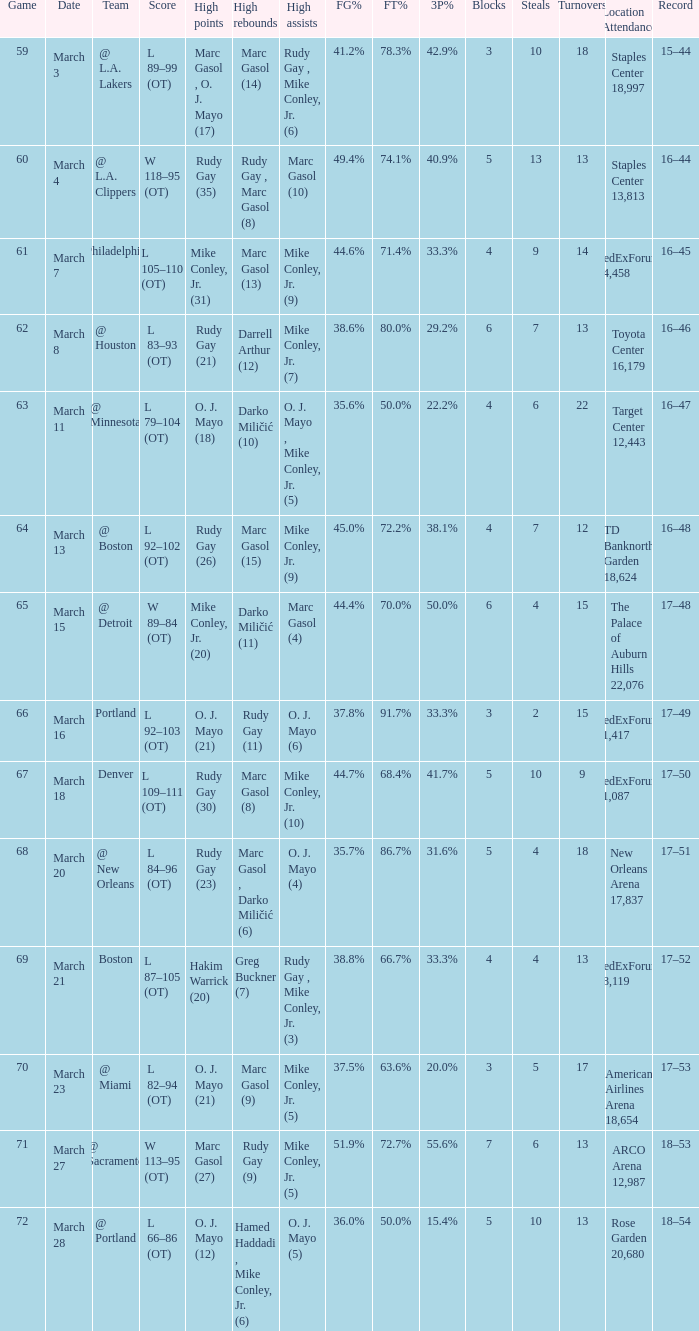What was the location and attendance for game 60? Staples Center 13,813. 